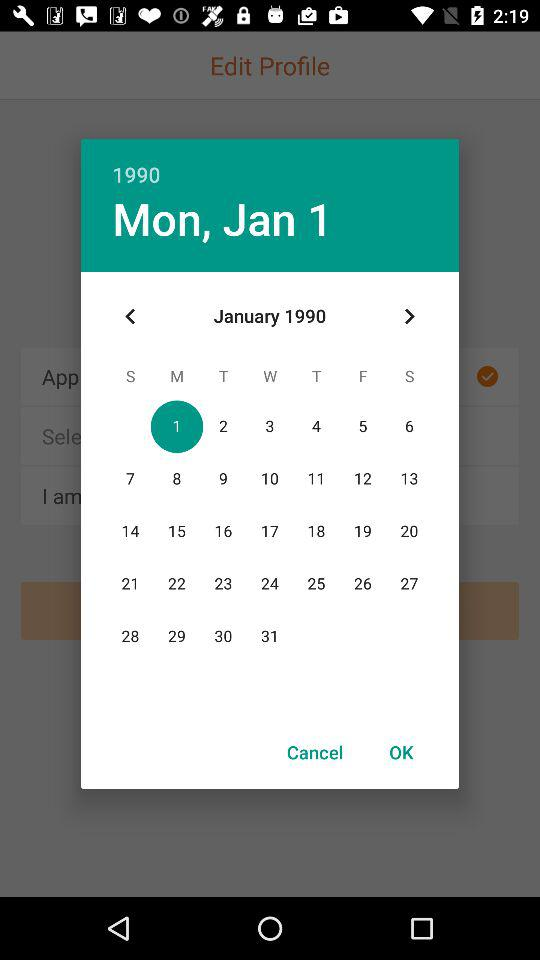Which month is selected on the calendar? The selected month on the calendar is January. 